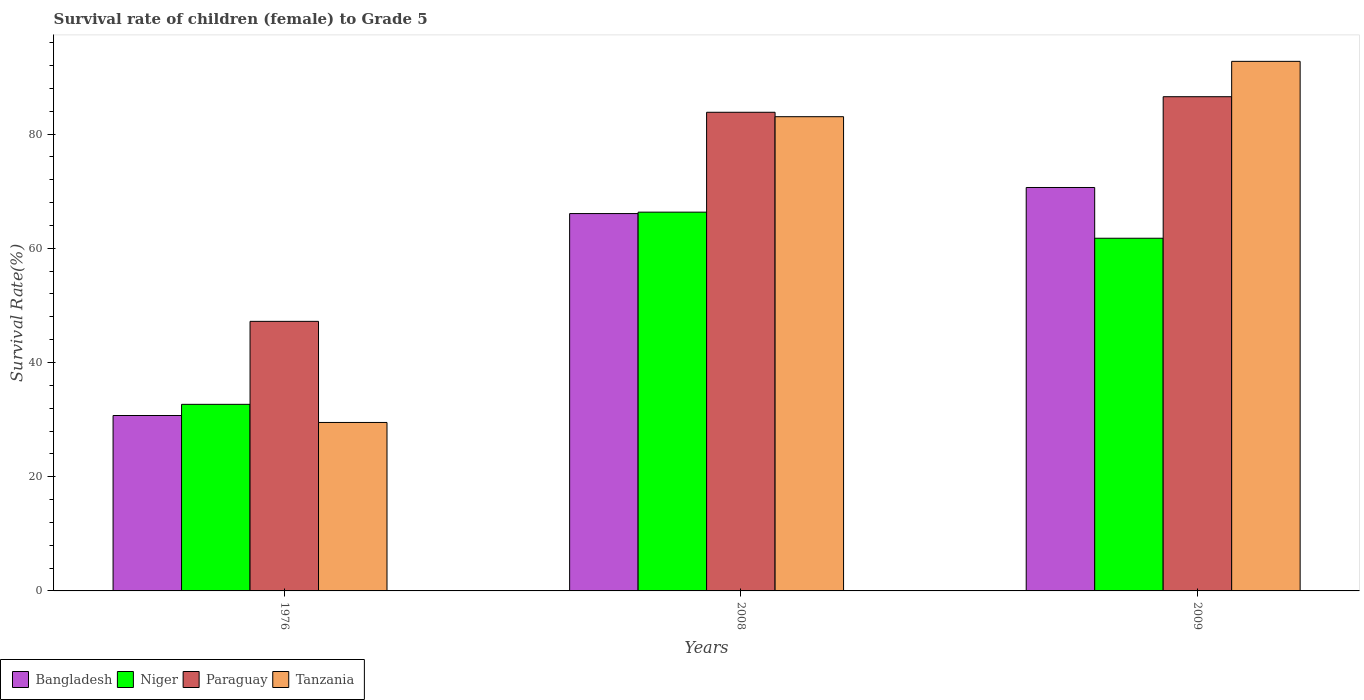What is the survival rate of female children to grade 5 in Niger in 2009?
Give a very brief answer. 61.75. Across all years, what is the maximum survival rate of female children to grade 5 in Niger?
Your answer should be very brief. 66.32. Across all years, what is the minimum survival rate of female children to grade 5 in Paraguay?
Ensure brevity in your answer.  47.2. In which year was the survival rate of female children to grade 5 in Tanzania maximum?
Your answer should be compact. 2009. In which year was the survival rate of female children to grade 5 in Niger minimum?
Offer a very short reply. 1976. What is the total survival rate of female children to grade 5 in Tanzania in the graph?
Ensure brevity in your answer.  205.25. What is the difference between the survival rate of female children to grade 5 in Tanzania in 1976 and that in 2009?
Offer a very short reply. -63.23. What is the difference between the survival rate of female children to grade 5 in Tanzania in 1976 and the survival rate of female children to grade 5 in Paraguay in 2009?
Ensure brevity in your answer.  -57.04. What is the average survival rate of female children to grade 5 in Tanzania per year?
Ensure brevity in your answer.  68.42. In the year 2009, what is the difference between the survival rate of female children to grade 5 in Bangladesh and survival rate of female children to grade 5 in Paraguay?
Provide a succinct answer. -15.9. What is the ratio of the survival rate of female children to grade 5 in Bangladesh in 1976 to that in 2009?
Offer a very short reply. 0.43. Is the survival rate of female children to grade 5 in Bangladesh in 1976 less than that in 2009?
Your answer should be compact. Yes. What is the difference between the highest and the second highest survival rate of female children to grade 5 in Bangladesh?
Offer a terse response. 4.57. What is the difference between the highest and the lowest survival rate of female children to grade 5 in Niger?
Keep it short and to the point. 33.65. What does the 4th bar from the left in 1976 represents?
Keep it short and to the point. Tanzania. What does the 3rd bar from the right in 2008 represents?
Your answer should be compact. Niger. Are all the bars in the graph horizontal?
Ensure brevity in your answer.  No. Does the graph contain any zero values?
Your answer should be compact. No. Does the graph contain grids?
Offer a very short reply. No. Where does the legend appear in the graph?
Offer a very short reply. Bottom left. How many legend labels are there?
Offer a terse response. 4. What is the title of the graph?
Offer a very short reply. Survival rate of children (female) to Grade 5. Does "Paraguay" appear as one of the legend labels in the graph?
Your answer should be very brief. Yes. What is the label or title of the X-axis?
Give a very brief answer. Years. What is the label or title of the Y-axis?
Provide a short and direct response. Survival Rate(%). What is the Survival Rate(%) in Bangladesh in 1976?
Your answer should be compact. 30.71. What is the Survival Rate(%) of Niger in 1976?
Offer a very short reply. 32.67. What is the Survival Rate(%) of Paraguay in 1976?
Offer a very short reply. 47.2. What is the Survival Rate(%) of Tanzania in 1976?
Keep it short and to the point. 29.5. What is the Survival Rate(%) of Bangladesh in 2008?
Make the answer very short. 66.07. What is the Survival Rate(%) of Niger in 2008?
Keep it short and to the point. 66.32. What is the Survival Rate(%) of Paraguay in 2008?
Offer a terse response. 83.81. What is the Survival Rate(%) in Tanzania in 2008?
Offer a very short reply. 83.03. What is the Survival Rate(%) of Bangladesh in 2009?
Offer a very short reply. 70.64. What is the Survival Rate(%) of Niger in 2009?
Your answer should be very brief. 61.75. What is the Survival Rate(%) of Paraguay in 2009?
Ensure brevity in your answer.  86.53. What is the Survival Rate(%) of Tanzania in 2009?
Provide a short and direct response. 92.72. Across all years, what is the maximum Survival Rate(%) in Bangladesh?
Offer a terse response. 70.64. Across all years, what is the maximum Survival Rate(%) of Niger?
Ensure brevity in your answer.  66.32. Across all years, what is the maximum Survival Rate(%) of Paraguay?
Your answer should be compact. 86.53. Across all years, what is the maximum Survival Rate(%) in Tanzania?
Your answer should be very brief. 92.72. Across all years, what is the minimum Survival Rate(%) in Bangladesh?
Offer a very short reply. 30.71. Across all years, what is the minimum Survival Rate(%) of Niger?
Keep it short and to the point. 32.67. Across all years, what is the minimum Survival Rate(%) in Paraguay?
Keep it short and to the point. 47.2. Across all years, what is the minimum Survival Rate(%) in Tanzania?
Offer a terse response. 29.5. What is the total Survival Rate(%) in Bangladesh in the graph?
Offer a very short reply. 167.42. What is the total Survival Rate(%) of Niger in the graph?
Keep it short and to the point. 160.74. What is the total Survival Rate(%) in Paraguay in the graph?
Offer a terse response. 217.54. What is the total Survival Rate(%) in Tanzania in the graph?
Keep it short and to the point. 205.25. What is the difference between the Survival Rate(%) of Bangladesh in 1976 and that in 2008?
Give a very brief answer. -35.36. What is the difference between the Survival Rate(%) of Niger in 1976 and that in 2008?
Keep it short and to the point. -33.65. What is the difference between the Survival Rate(%) of Paraguay in 1976 and that in 2008?
Offer a very short reply. -36.61. What is the difference between the Survival Rate(%) in Tanzania in 1976 and that in 2008?
Your response must be concise. -53.54. What is the difference between the Survival Rate(%) of Bangladesh in 1976 and that in 2009?
Your answer should be compact. -39.92. What is the difference between the Survival Rate(%) of Niger in 1976 and that in 2009?
Your answer should be compact. -29.08. What is the difference between the Survival Rate(%) in Paraguay in 1976 and that in 2009?
Make the answer very short. -39.33. What is the difference between the Survival Rate(%) in Tanzania in 1976 and that in 2009?
Keep it short and to the point. -63.23. What is the difference between the Survival Rate(%) of Bangladesh in 2008 and that in 2009?
Your answer should be compact. -4.57. What is the difference between the Survival Rate(%) of Niger in 2008 and that in 2009?
Make the answer very short. 4.57. What is the difference between the Survival Rate(%) of Paraguay in 2008 and that in 2009?
Give a very brief answer. -2.72. What is the difference between the Survival Rate(%) of Tanzania in 2008 and that in 2009?
Your answer should be compact. -9.69. What is the difference between the Survival Rate(%) in Bangladesh in 1976 and the Survival Rate(%) in Niger in 2008?
Make the answer very short. -35.61. What is the difference between the Survival Rate(%) in Bangladesh in 1976 and the Survival Rate(%) in Paraguay in 2008?
Offer a terse response. -53.09. What is the difference between the Survival Rate(%) in Bangladesh in 1976 and the Survival Rate(%) in Tanzania in 2008?
Your answer should be compact. -52.32. What is the difference between the Survival Rate(%) of Niger in 1976 and the Survival Rate(%) of Paraguay in 2008?
Ensure brevity in your answer.  -51.14. What is the difference between the Survival Rate(%) of Niger in 1976 and the Survival Rate(%) of Tanzania in 2008?
Provide a short and direct response. -50.36. What is the difference between the Survival Rate(%) of Paraguay in 1976 and the Survival Rate(%) of Tanzania in 2008?
Give a very brief answer. -35.83. What is the difference between the Survival Rate(%) in Bangladesh in 1976 and the Survival Rate(%) in Niger in 2009?
Your answer should be compact. -31.04. What is the difference between the Survival Rate(%) of Bangladesh in 1976 and the Survival Rate(%) of Paraguay in 2009?
Provide a succinct answer. -55.82. What is the difference between the Survival Rate(%) of Bangladesh in 1976 and the Survival Rate(%) of Tanzania in 2009?
Offer a terse response. -62.01. What is the difference between the Survival Rate(%) of Niger in 1976 and the Survival Rate(%) of Paraguay in 2009?
Give a very brief answer. -53.86. What is the difference between the Survival Rate(%) in Niger in 1976 and the Survival Rate(%) in Tanzania in 2009?
Offer a terse response. -60.05. What is the difference between the Survival Rate(%) of Paraguay in 1976 and the Survival Rate(%) of Tanzania in 2009?
Your answer should be compact. -45.52. What is the difference between the Survival Rate(%) of Bangladesh in 2008 and the Survival Rate(%) of Niger in 2009?
Ensure brevity in your answer.  4.32. What is the difference between the Survival Rate(%) in Bangladesh in 2008 and the Survival Rate(%) in Paraguay in 2009?
Make the answer very short. -20.46. What is the difference between the Survival Rate(%) of Bangladesh in 2008 and the Survival Rate(%) of Tanzania in 2009?
Provide a succinct answer. -26.65. What is the difference between the Survival Rate(%) of Niger in 2008 and the Survival Rate(%) of Paraguay in 2009?
Offer a terse response. -20.21. What is the difference between the Survival Rate(%) in Niger in 2008 and the Survival Rate(%) in Tanzania in 2009?
Your answer should be very brief. -26.4. What is the difference between the Survival Rate(%) in Paraguay in 2008 and the Survival Rate(%) in Tanzania in 2009?
Ensure brevity in your answer.  -8.91. What is the average Survival Rate(%) in Bangladesh per year?
Ensure brevity in your answer.  55.81. What is the average Survival Rate(%) in Niger per year?
Provide a succinct answer. 53.58. What is the average Survival Rate(%) in Paraguay per year?
Make the answer very short. 72.51. What is the average Survival Rate(%) of Tanzania per year?
Offer a terse response. 68.42. In the year 1976, what is the difference between the Survival Rate(%) in Bangladesh and Survival Rate(%) in Niger?
Your response must be concise. -1.96. In the year 1976, what is the difference between the Survival Rate(%) in Bangladesh and Survival Rate(%) in Paraguay?
Provide a short and direct response. -16.49. In the year 1976, what is the difference between the Survival Rate(%) in Bangladesh and Survival Rate(%) in Tanzania?
Keep it short and to the point. 1.22. In the year 1976, what is the difference between the Survival Rate(%) in Niger and Survival Rate(%) in Paraguay?
Provide a succinct answer. -14.53. In the year 1976, what is the difference between the Survival Rate(%) in Niger and Survival Rate(%) in Tanzania?
Offer a terse response. 3.17. In the year 1976, what is the difference between the Survival Rate(%) in Paraguay and Survival Rate(%) in Tanzania?
Offer a very short reply. 17.7. In the year 2008, what is the difference between the Survival Rate(%) of Bangladesh and Survival Rate(%) of Niger?
Your answer should be very brief. -0.25. In the year 2008, what is the difference between the Survival Rate(%) of Bangladesh and Survival Rate(%) of Paraguay?
Your response must be concise. -17.74. In the year 2008, what is the difference between the Survival Rate(%) of Bangladesh and Survival Rate(%) of Tanzania?
Give a very brief answer. -16.96. In the year 2008, what is the difference between the Survival Rate(%) in Niger and Survival Rate(%) in Paraguay?
Keep it short and to the point. -17.49. In the year 2008, what is the difference between the Survival Rate(%) in Niger and Survival Rate(%) in Tanzania?
Ensure brevity in your answer.  -16.71. In the year 2008, what is the difference between the Survival Rate(%) of Paraguay and Survival Rate(%) of Tanzania?
Your answer should be very brief. 0.78. In the year 2009, what is the difference between the Survival Rate(%) in Bangladesh and Survival Rate(%) in Niger?
Make the answer very short. 8.89. In the year 2009, what is the difference between the Survival Rate(%) in Bangladesh and Survival Rate(%) in Paraguay?
Make the answer very short. -15.9. In the year 2009, what is the difference between the Survival Rate(%) in Bangladesh and Survival Rate(%) in Tanzania?
Ensure brevity in your answer.  -22.09. In the year 2009, what is the difference between the Survival Rate(%) of Niger and Survival Rate(%) of Paraguay?
Keep it short and to the point. -24.78. In the year 2009, what is the difference between the Survival Rate(%) of Niger and Survival Rate(%) of Tanzania?
Your answer should be compact. -30.97. In the year 2009, what is the difference between the Survival Rate(%) in Paraguay and Survival Rate(%) in Tanzania?
Provide a succinct answer. -6.19. What is the ratio of the Survival Rate(%) in Bangladesh in 1976 to that in 2008?
Your response must be concise. 0.46. What is the ratio of the Survival Rate(%) of Niger in 1976 to that in 2008?
Ensure brevity in your answer.  0.49. What is the ratio of the Survival Rate(%) of Paraguay in 1976 to that in 2008?
Your response must be concise. 0.56. What is the ratio of the Survival Rate(%) in Tanzania in 1976 to that in 2008?
Make the answer very short. 0.36. What is the ratio of the Survival Rate(%) in Bangladesh in 1976 to that in 2009?
Provide a short and direct response. 0.43. What is the ratio of the Survival Rate(%) in Niger in 1976 to that in 2009?
Your response must be concise. 0.53. What is the ratio of the Survival Rate(%) in Paraguay in 1976 to that in 2009?
Your answer should be compact. 0.55. What is the ratio of the Survival Rate(%) of Tanzania in 1976 to that in 2009?
Offer a terse response. 0.32. What is the ratio of the Survival Rate(%) in Bangladesh in 2008 to that in 2009?
Your answer should be very brief. 0.94. What is the ratio of the Survival Rate(%) of Niger in 2008 to that in 2009?
Provide a short and direct response. 1.07. What is the ratio of the Survival Rate(%) of Paraguay in 2008 to that in 2009?
Give a very brief answer. 0.97. What is the ratio of the Survival Rate(%) of Tanzania in 2008 to that in 2009?
Your answer should be very brief. 0.9. What is the difference between the highest and the second highest Survival Rate(%) of Bangladesh?
Provide a short and direct response. 4.57. What is the difference between the highest and the second highest Survival Rate(%) of Niger?
Ensure brevity in your answer.  4.57. What is the difference between the highest and the second highest Survival Rate(%) of Paraguay?
Keep it short and to the point. 2.72. What is the difference between the highest and the second highest Survival Rate(%) of Tanzania?
Offer a terse response. 9.69. What is the difference between the highest and the lowest Survival Rate(%) in Bangladesh?
Provide a succinct answer. 39.92. What is the difference between the highest and the lowest Survival Rate(%) in Niger?
Your answer should be very brief. 33.65. What is the difference between the highest and the lowest Survival Rate(%) of Paraguay?
Provide a succinct answer. 39.33. What is the difference between the highest and the lowest Survival Rate(%) of Tanzania?
Your response must be concise. 63.23. 